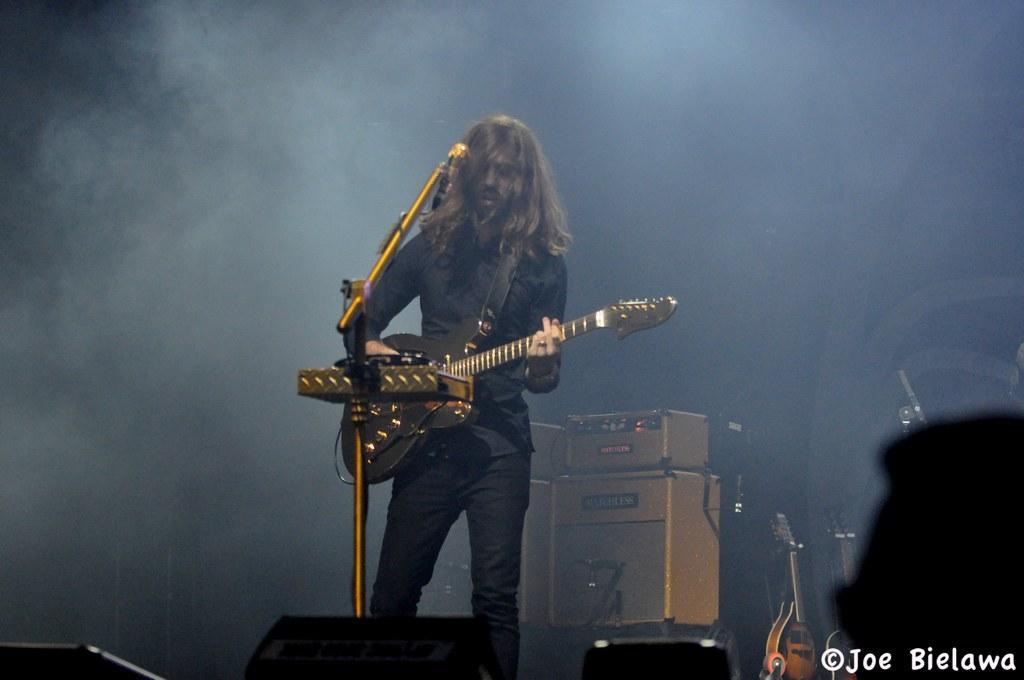Could you give a brief overview of what you see in this image? In this picture we can see a man is holding a guitar, In front of the man there is a microphone with the stands. Behind the man there are some music systems, musical instruments, smoke and dark background. On the image there is a watermark. 